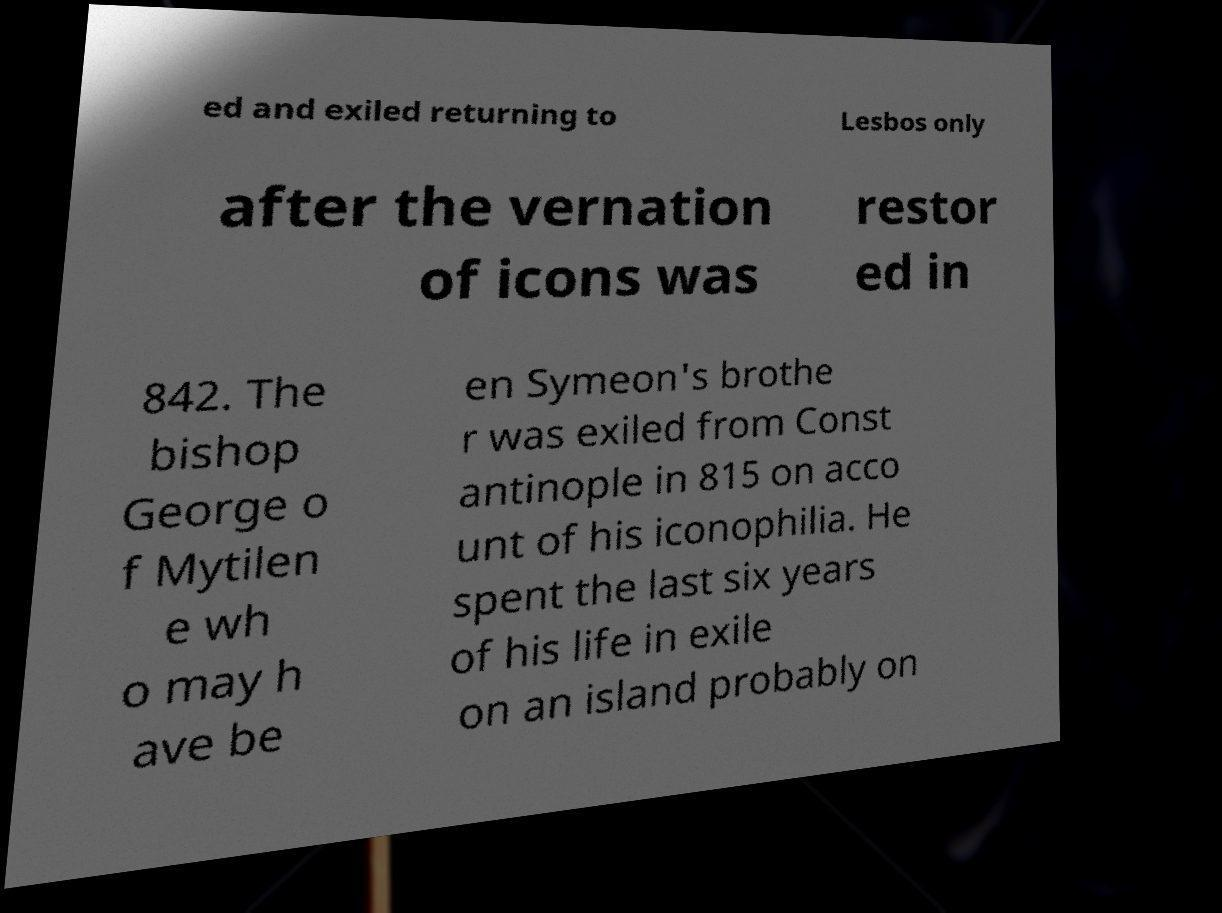What messages or text are displayed in this image? I need them in a readable, typed format. ed and exiled returning to Lesbos only after the vernation of icons was restor ed in 842. The bishop George o f Mytilen e wh o may h ave be en Symeon's brothe r was exiled from Const antinople in 815 on acco unt of his iconophilia. He spent the last six years of his life in exile on an island probably on 